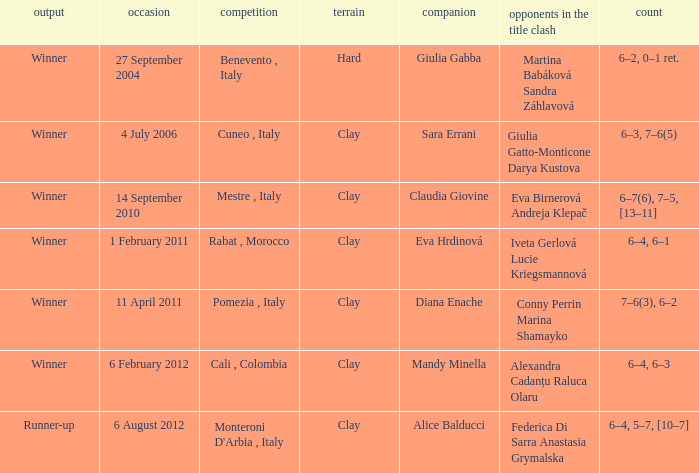Who played on a hard surface? Giulia Gabba. 